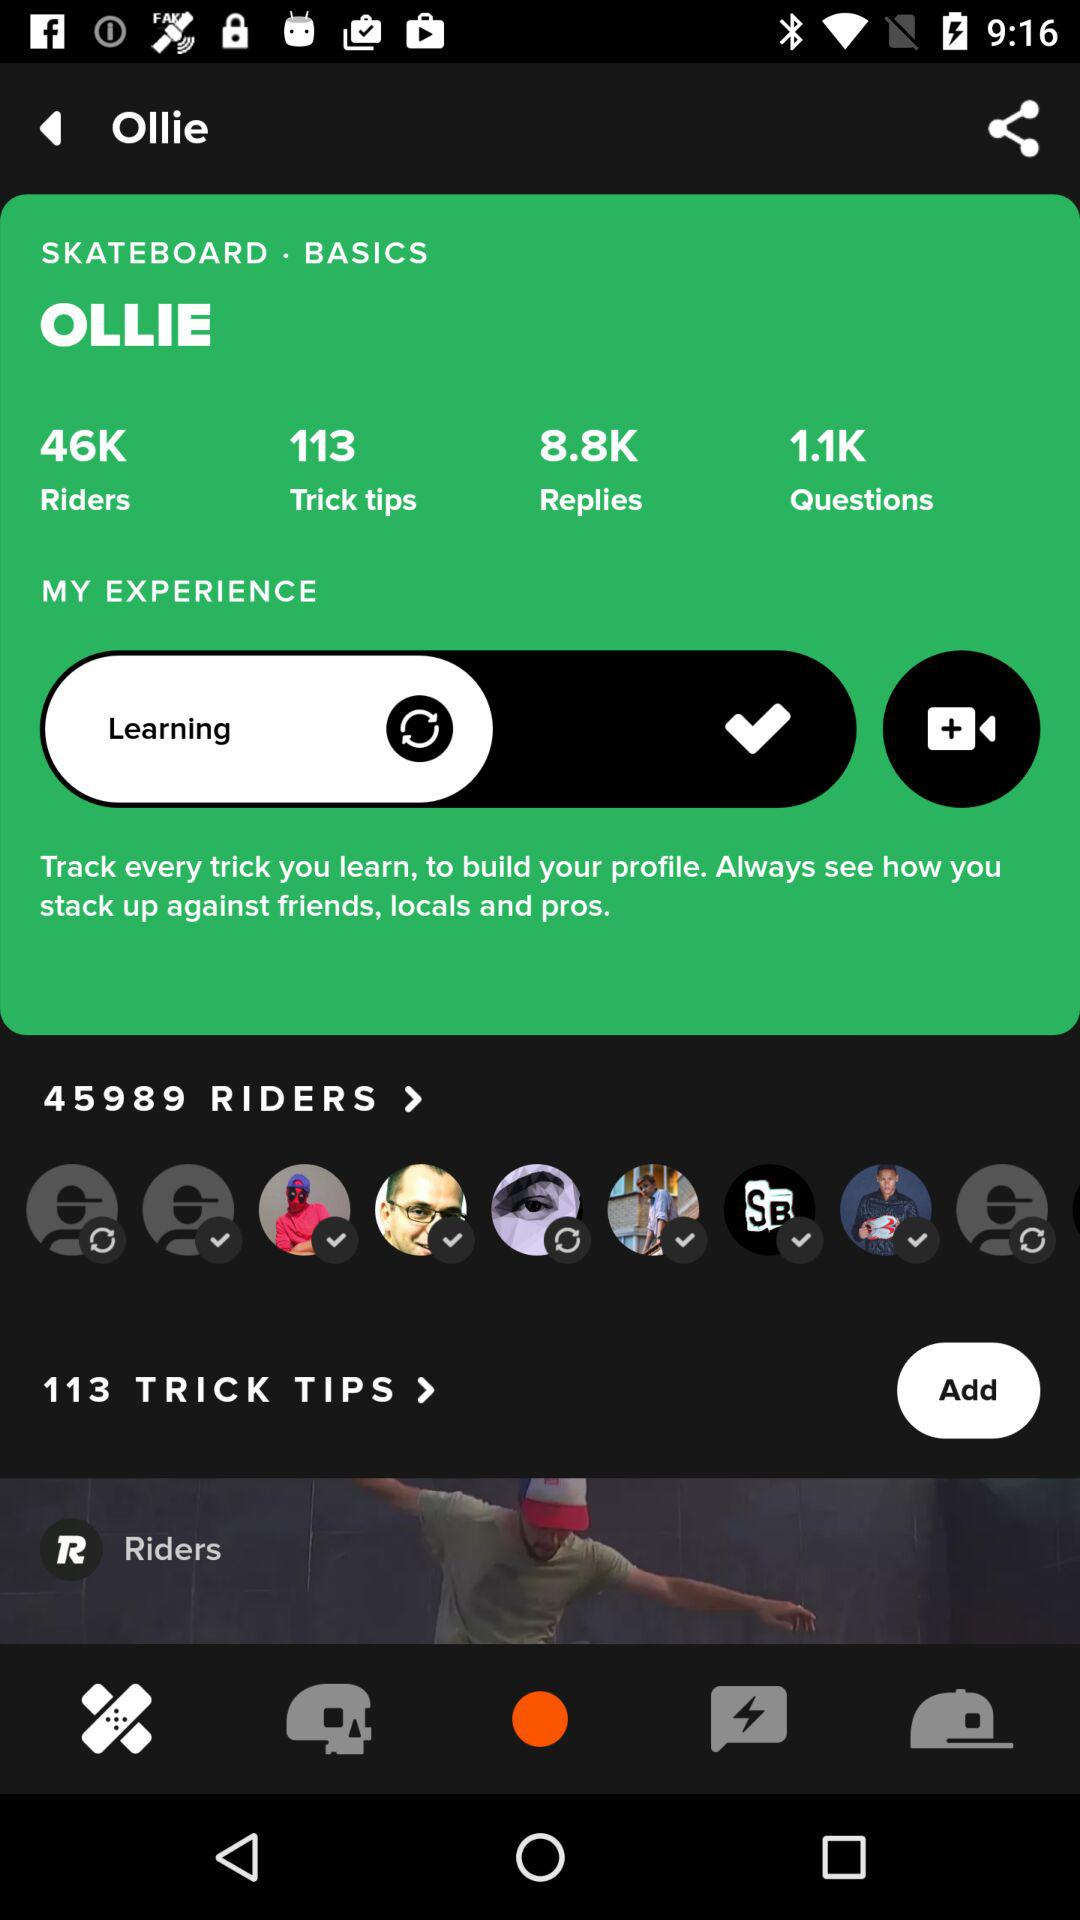What is the count of replies? The count of replies is 8.8K. 